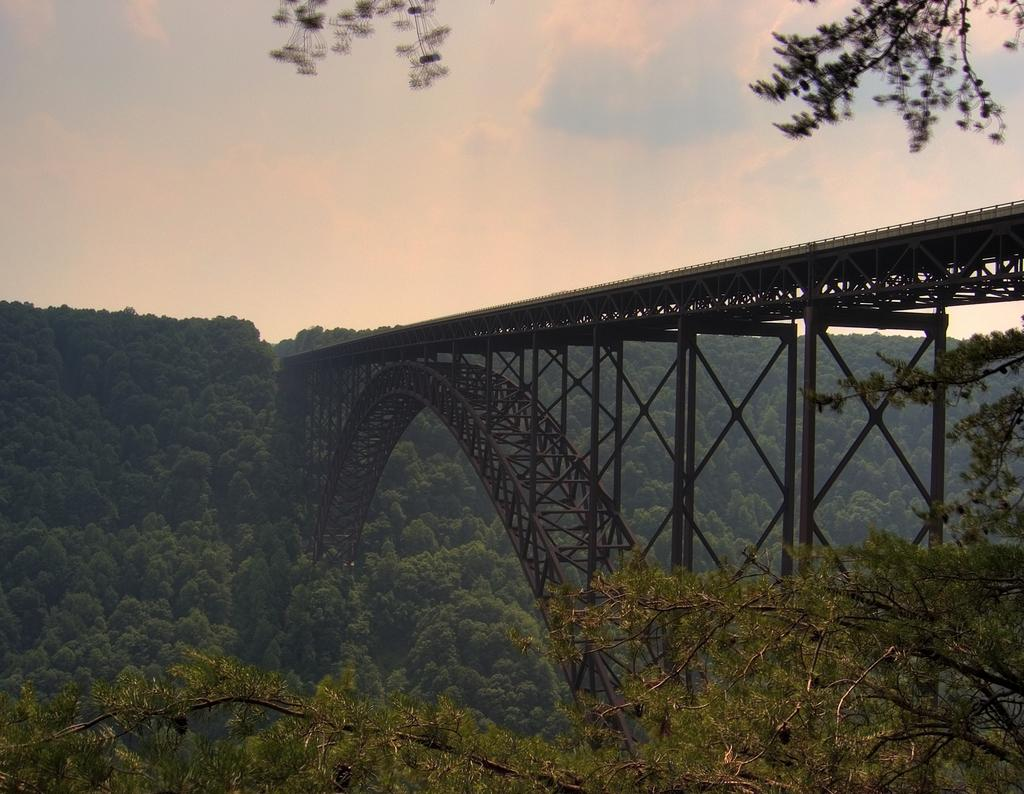What structure is present in the image? There is a bridge in the image. What colors are used to depict the bridge? The bridge is in black and brown color. What type of vegetation can be seen in the image? There are trees in the image. What is the color of the sky in the image? The sky is blue and white in color. How many books are stacked on the bridge in the image? There are no books present on the bridge in the image. Can you see a beetle crawling on the trees in the image? There is no beetle visible on the trees in the image. 